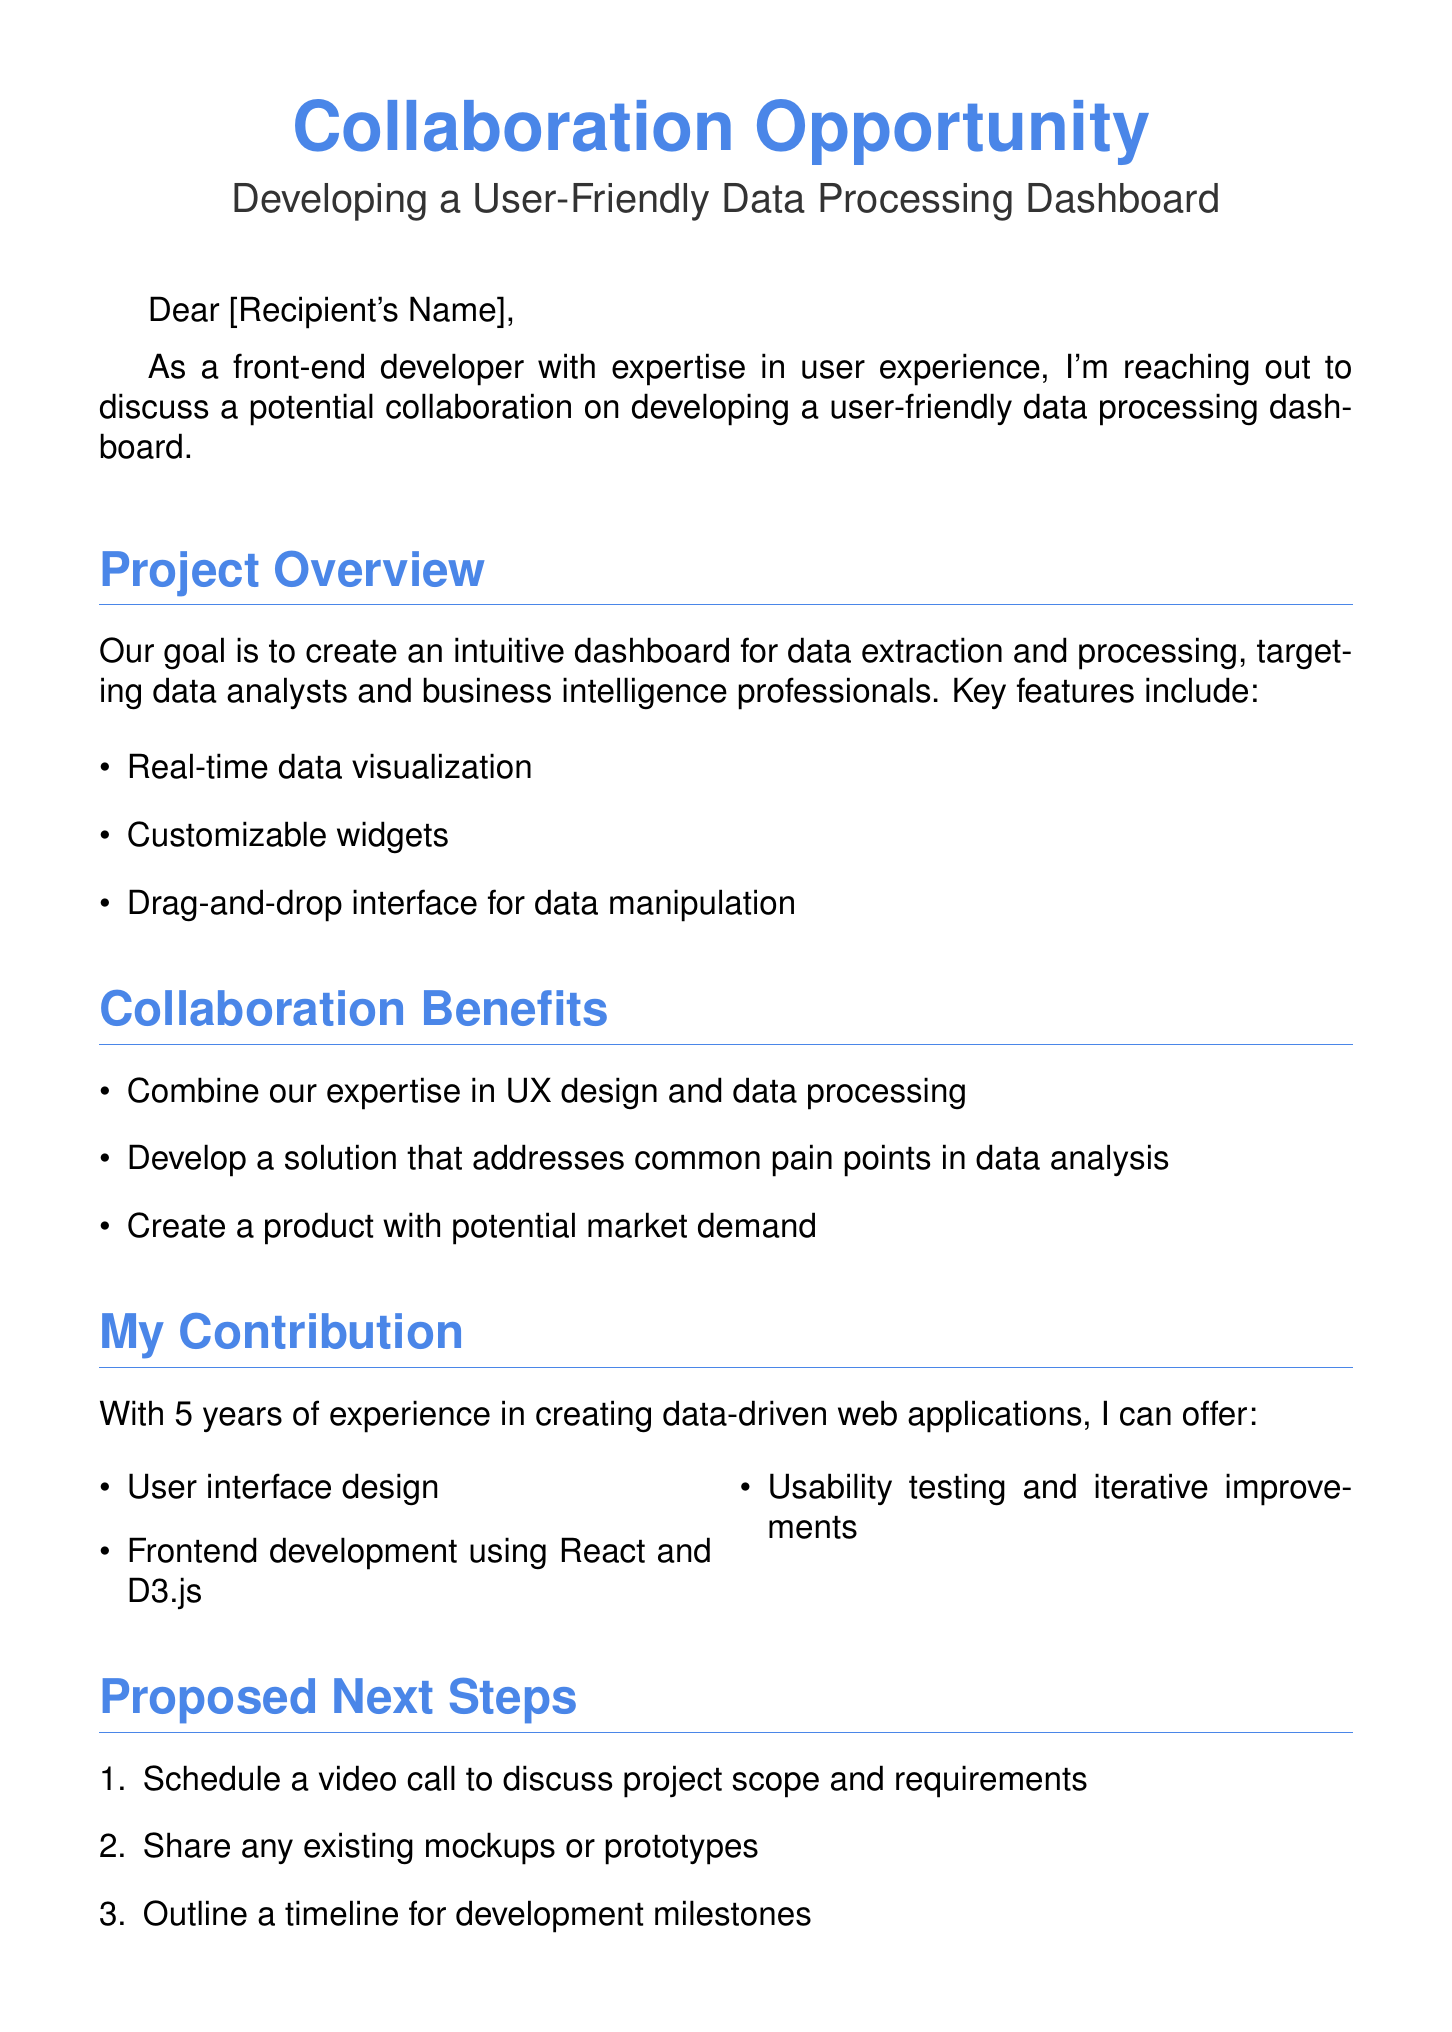What is the subject of the email? The subject line of the email provides the main topic, which is a collaboration opportunity for developing a user-friendly data processing dashboard.
Answer: Collaboration Opportunity: Developing a User-Friendly Data Processing Dashboard Who is the intended target user of the dashboard? The document specifies that the dashboard is aimed at specific professionals, providing insight into the primary users.
Answer: Data analysts and business intelligence professionals What are two key features of the proposed dashboard? The email lists key features, showcasing what the dashboard aims to provide for better usability.
Answer: Real-time data visualization, Customizable widgets How many years of experience does the sender have? The sender's experience is mentioned explicitly, providing context about their qualifications for the project.
Answer: 5 years What is the proposed first step in the collaboration process? The email outlines specific next steps, indicating how the collaboration could initiate and progress.
Answer: Schedule a video call to discuss project scope and requirements What is the main goal of developing the dashboard? The document clearly states the overall aim of the project, providing a focus for the collaboration.
Answer: Create an intuitive dashboard for data extraction and processing Why is the collaboration beneficial according to the email? The email describes various benefits that would arise from the collaboration, emphasizing value creation.
Answer: Combine our expertise in UX design and data processing What development tools will be used for frontend development? The sender mentions specific technologies they are proficient in, highlighting the technical skills available for the project.
Answer: React and D3.js 